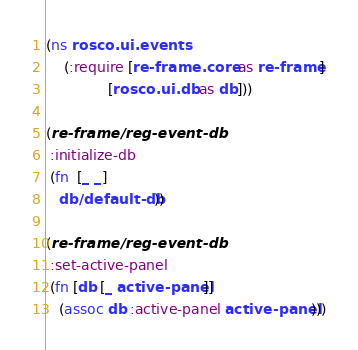Convert code to text. <code><loc_0><loc_0><loc_500><loc_500><_Clojure_>(ns rosco.ui.events
    (:require [re-frame.core :as re-frame]
              [rosco.ui.db :as db]))

(re-frame/reg-event-db
 :initialize-db
 (fn  [_ _]
   db/default-db))

(re-frame/reg-event-db
 :set-active-panel
 (fn [db [_ active-panel]]
   (assoc db :active-panel active-panel)))
</code> 